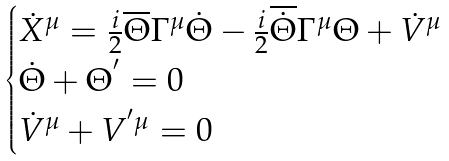Convert formula to latex. <formula><loc_0><loc_0><loc_500><loc_500>\begin{cases} { \dot { X } } ^ { \mu } = \frac { i } { 2 } \overline { \Theta } { \Gamma } ^ { \mu } \dot { \Theta } - \frac { i } { 2 } \overline { \dot { \Theta } } { \Gamma } ^ { \mu } \Theta + { \dot { V } } ^ { \mu } \\ \dot { \Theta } + { \Theta } ^ { ^ { \prime } } = 0 \\ { \dot { V } } ^ { \mu } + V ^ { ^ { \prime } \mu } = 0 \end{cases}</formula> 